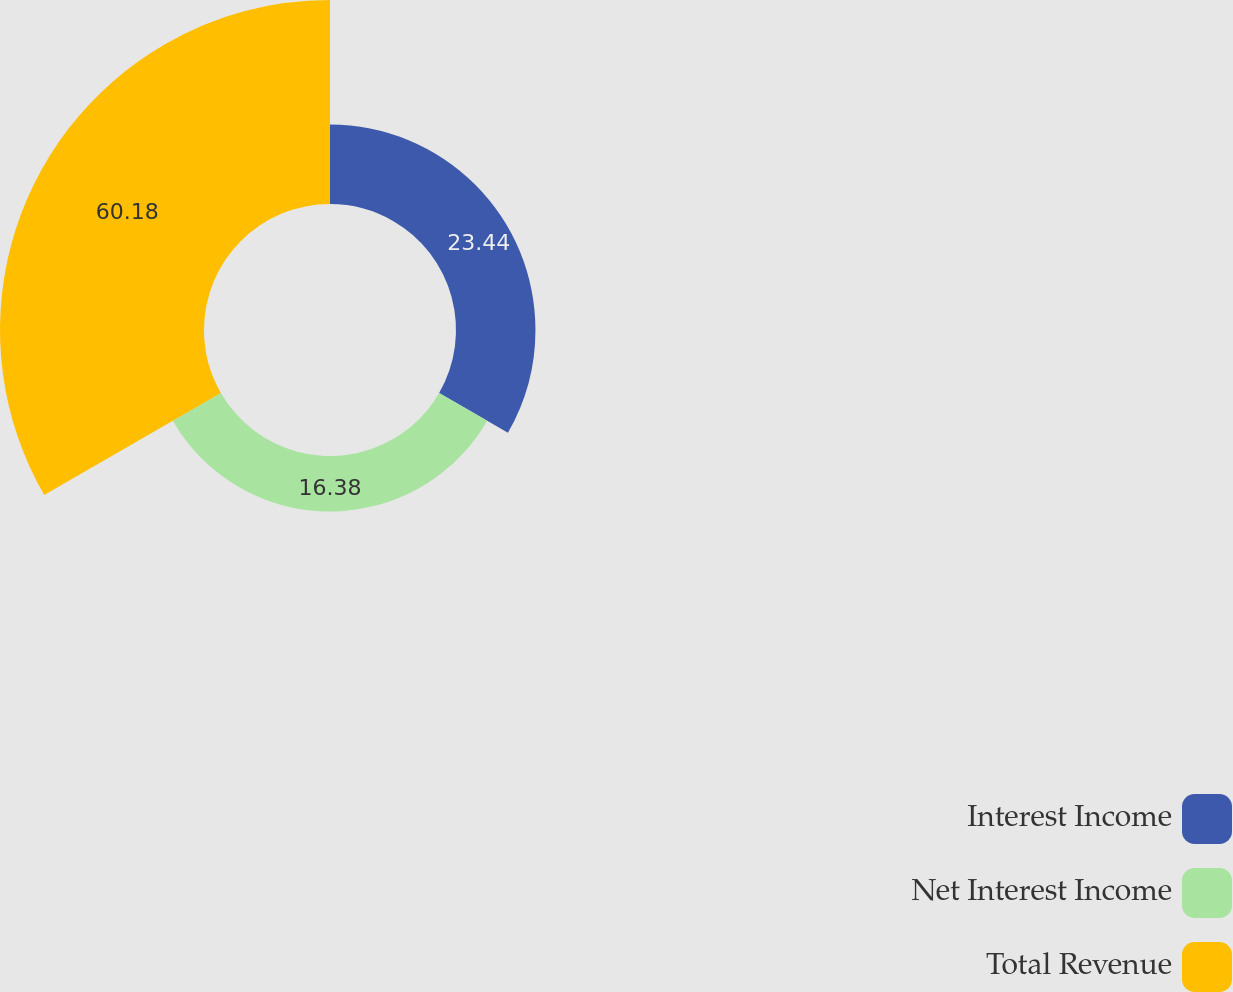<chart> <loc_0><loc_0><loc_500><loc_500><pie_chart><fcel>Interest Income<fcel>Net Interest Income<fcel>Total Revenue<nl><fcel>23.44%<fcel>16.38%<fcel>60.18%<nl></chart> 